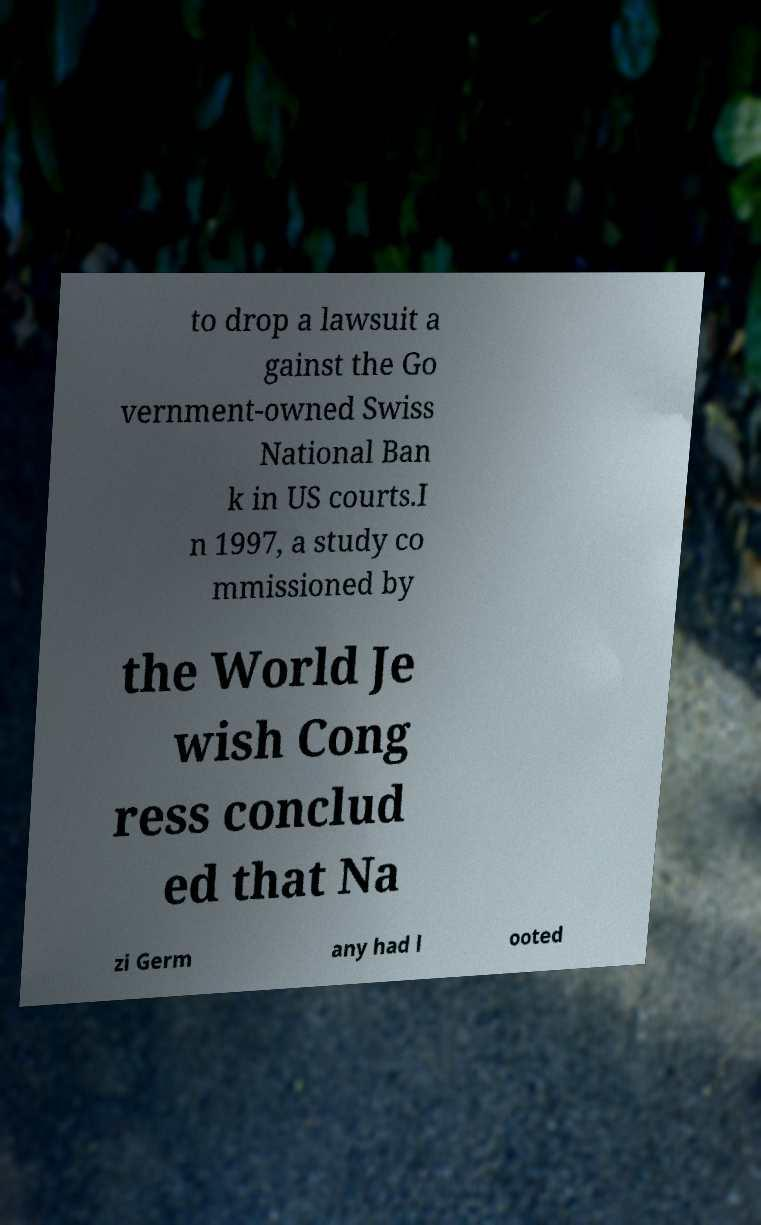Could you extract and type out the text from this image? to drop a lawsuit a gainst the Go vernment-owned Swiss National Ban k in US courts.I n 1997, a study co mmissioned by the World Je wish Cong ress conclud ed that Na zi Germ any had l ooted 